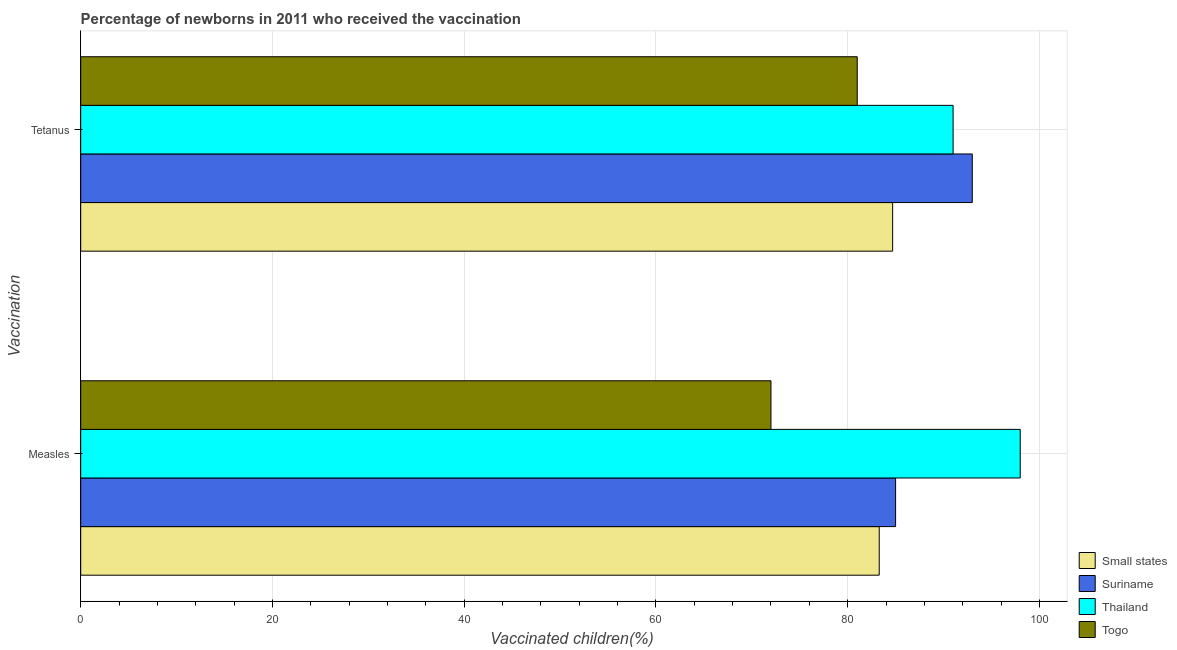How many different coloured bars are there?
Make the answer very short. 4. How many groups of bars are there?
Give a very brief answer. 2. Are the number of bars per tick equal to the number of legend labels?
Keep it short and to the point. Yes. How many bars are there on the 2nd tick from the top?
Offer a terse response. 4. How many bars are there on the 1st tick from the bottom?
Provide a short and direct response. 4. What is the label of the 1st group of bars from the top?
Offer a very short reply. Tetanus. Across all countries, what is the minimum percentage of newborns who received vaccination for tetanus?
Your answer should be compact. 81. In which country was the percentage of newborns who received vaccination for tetanus maximum?
Your answer should be very brief. Suriname. In which country was the percentage of newborns who received vaccination for measles minimum?
Provide a short and direct response. Togo. What is the total percentage of newborns who received vaccination for measles in the graph?
Keep it short and to the point. 338.29. What is the difference between the percentage of newborns who received vaccination for tetanus in Small states and that in Suriname?
Your answer should be compact. -8.31. What is the difference between the percentage of newborns who received vaccination for measles in Togo and the percentage of newborns who received vaccination for tetanus in Suriname?
Your answer should be very brief. -21. What is the average percentage of newborns who received vaccination for tetanus per country?
Provide a succinct answer. 87.42. In how many countries, is the percentage of newborns who received vaccination for tetanus greater than 80 %?
Offer a very short reply. 4. What is the ratio of the percentage of newborns who received vaccination for measles in Thailand to that in Togo?
Provide a succinct answer. 1.36. In how many countries, is the percentage of newborns who received vaccination for measles greater than the average percentage of newborns who received vaccination for measles taken over all countries?
Offer a very short reply. 2. What does the 4th bar from the top in Measles represents?
Your answer should be very brief. Small states. What does the 1st bar from the bottom in Measles represents?
Keep it short and to the point. Small states. How many bars are there?
Your answer should be compact. 8. Are all the bars in the graph horizontal?
Provide a short and direct response. Yes. How many countries are there in the graph?
Your answer should be very brief. 4. Does the graph contain any zero values?
Provide a short and direct response. No. Does the graph contain grids?
Offer a very short reply. Yes. Where does the legend appear in the graph?
Your answer should be compact. Bottom right. How many legend labels are there?
Give a very brief answer. 4. What is the title of the graph?
Your answer should be very brief. Percentage of newborns in 2011 who received the vaccination. What is the label or title of the X-axis?
Offer a terse response. Vaccinated children(%)
. What is the label or title of the Y-axis?
Provide a succinct answer. Vaccination. What is the Vaccinated children(%)
 of Small states in Measles?
Provide a succinct answer. 83.29. What is the Vaccinated children(%)
 in Suriname in Measles?
Offer a very short reply. 85. What is the Vaccinated children(%)
 in Thailand in Measles?
Give a very brief answer. 98. What is the Vaccinated children(%)
 of Togo in Measles?
Offer a very short reply. 72. What is the Vaccinated children(%)
 of Small states in Tetanus?
Keep it short and to the point. 84.69. What is the Vaccinated children(%)
 of Suriname in Tetanus?
Make the answer very short. 93. What is the Vaccinated children(%)
 of Thailand in Tetanus?
Give a very brief answer. 91. Across all Vaccination, what is the maximum Vaccinated children(%)
 of Small states?
Your answer should be compact. 84.69. Across all Vaccination, what is the maximum Vaccinated children(%)
 of Suriname?
Make the answer very short. 93. Across all Vaccination, what is the maximum Vaccinated children(%)
 in Thailand?
Offer a very short reply. 98. Across all Vaccination, what is the minimum Vaccinated children(%)
 of Small states?
Give a very brief answer. 83.29. Across all Vaccination, what is the minimum Vaccinated children(%)
 of Thailand?
Give a very brief answer. 91. Across all Vaccination, what is the minimum Vaccinated children(%)
 of Togo?
Make the answer very short. 72. What is the total Vaccinated children(%)
 in Small states in the graph?
Your answer should be compact. 167.98. What is the total Vaccinated children(%)
 in Suriname in the graph?
Your response must be concise. 178. What is the total Vaccinated children(%)
 in Thailand in the graph?
Ensure brevity in your answer.  189. What is the total Vaccinated children(%)
 in Togo in the graph?
Offer a terse response. 153. What is the difference between the Vaccinated children(%)
 of Small states in Measles and that in Tetanus?
Your response must be concise. -1.4. What is the difference between the Vaccinated children(%)
 in Suriname in Measles and that in Tetanus?
Your answer should be compact. -8. What is the difference between the Vaccinated children(%)
 in Small states in Measles and the Vaccinated children(%)
 in Suriname in Tetanus?
Ensure brevity in your answer.  -9.71. What is the difference between the Vaccinated children(%)
 in Small states in Measles and the Vaccinated children(%)
 in Thailand in Tetanus?
Provide a short and direct response. -7.71. What is the difference between the Vaccinated children(%)
 of Small states in Measles and the Vaccinated children(%)
 of Togo in Tetanus?
Your answer should be very brief. 2.29. What is the difference between the Vaccinated children(%)
 of Suriname in Measles and the Vaccinated children(%)
 of Togo in Tetanus?
Offer a very short reply. 4. What is the average Vaccinated children(%)
 in Small states per Vaccination?
Your answer should be compact. 83.99. What is the average Vaccinated children(%)
 of Suriname per Vaccination?
Offer a very short reply. 89. What is the average Vaccinated children(%)
 of Thailand per Vaccination?
Give a very brief answer. 94.5. What is the average Vaccinated children(%)
 of Togo per Vaccination?
Your response must be concise. 76.5. What is the difference between the Vaccinated children(%)
 of Small states and Vaccinated children(%)
 of Suriname in Measles?
Offer a terse response. -1.71. What is the difference between the Vaccinated children(%)
 in Small states and Vaccinated children(%)
 in Thailand in Measles?
Your answer should be very brief. -14.71. What is the difference between the Vaccinated children(%)
 in Small states and Vaccinated children(%)
 in Togo in Measles?
Offer a very short reply. 11.29. What is the difference between the Vaccinated children(%)
 in Suriname and Vaccinated children(%)
 in Thailand in Measles?
Make the answer very short. -13. What is the difference between the Vaccinated children(%)
 of Thailand and Vaccinated children(%)
 of Togo in Measles?
Offer a terse response. 26. What is the difference between the Vaccinated children(%)
 of Small states and Vaccinated children(%)
 of Suriname in Tetanus?
Keep it short and to the point. -8.31. What is the difference between the Vaccinated children(%)
 in Small states and Vaccinated children(%)
 in Thailand in Tetanus?
Provide a short and direct response. -6.31. What is the difference between the Vaccinated children(%)
 of Small states and Vaccinated children(%)
 of Togo in Tetanus?
Make the answer very short. 3.69. What is the ratio of the Vaccinated children(%)
 of Small states in Measles to that in Tetanus?
Your response must be concise. 0.98. What is the ratio of the Vaccinated children(%)
 in Suriname in Measles to that in Tetanus?
Offer a terse response. 0.91. What is the ratio of the Vaccinated children(%)
 in Thailand in Measles to that in Tetanus?
Ensure brevity in your answer.  1.08. What is the difference between the highest and the second highest Vaccinated children(%)
 of Small states?
Make the answer very short. 1.4. What is the difference between the highest and the second highest Vaccinated children(%)
 of Suriname?
Provide a succinct answer. 8. What is the difference between the highest and the second highest Vaccinated children(%)
 of Togo?
Keep it short and to the point. 9. What is the difference between the highest and the lowest Vaccinated children(%)
 in Small states?
Keep it short and to the point. 1.4. What is the difference between the highest and the lowest Vaccinated children(%)
 of Suriname?
Offer a very short reply. 8. What is the difference between the highest and the lowest Vaccinated children(%)
 in Togo?
Your answer should be compact. 9. 